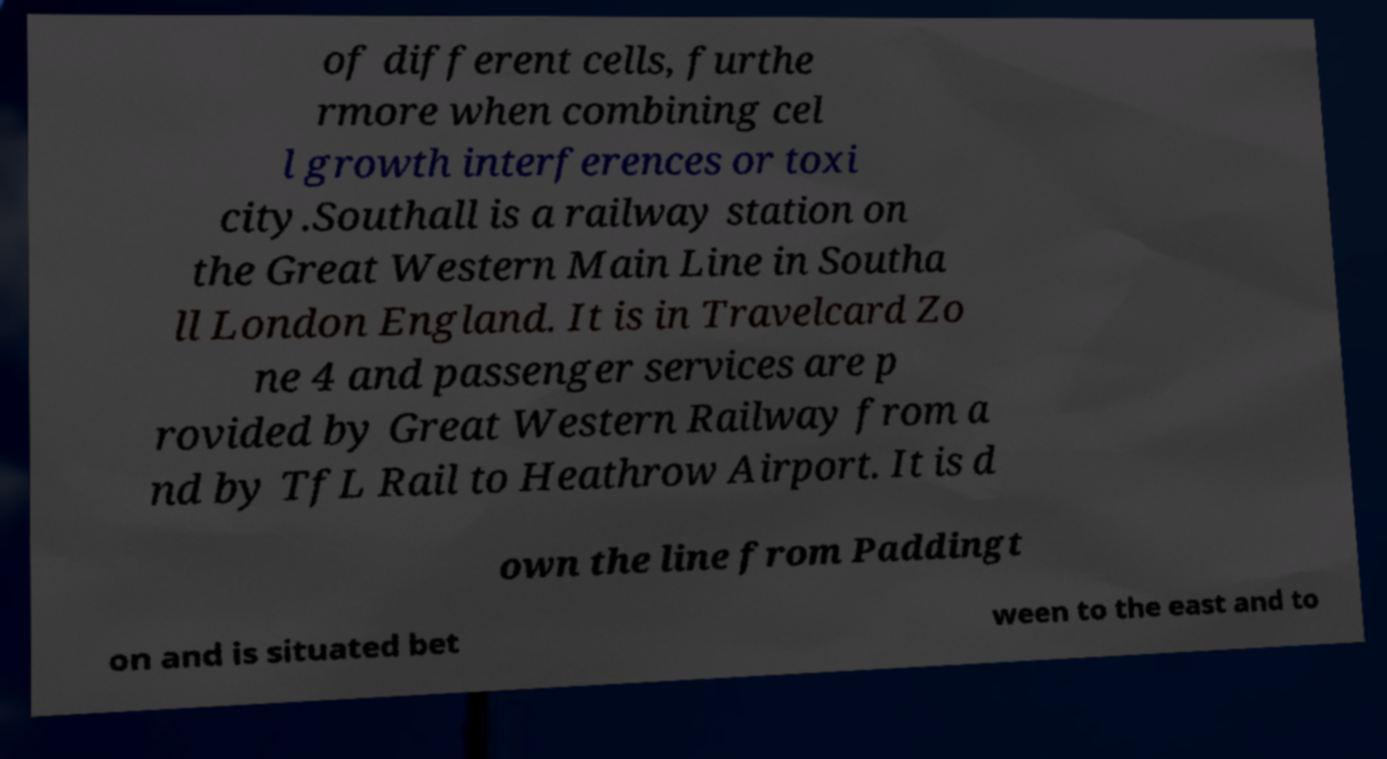Could you assist in decoding the text presented in this image and type it out clearly? of different cells, furthe rmore when combining cel l growth interferences or toxi city.Southall is a railway station on the Great Western Main Line in Southa ll London England. It is in Travelcard Zo ne 4 and passenger services are p rovided by Great Western Railway from a nd by TfL Rail to Heathrow Airport. It is d own the line from Paddingt on and is situated bet ween to the east and to 